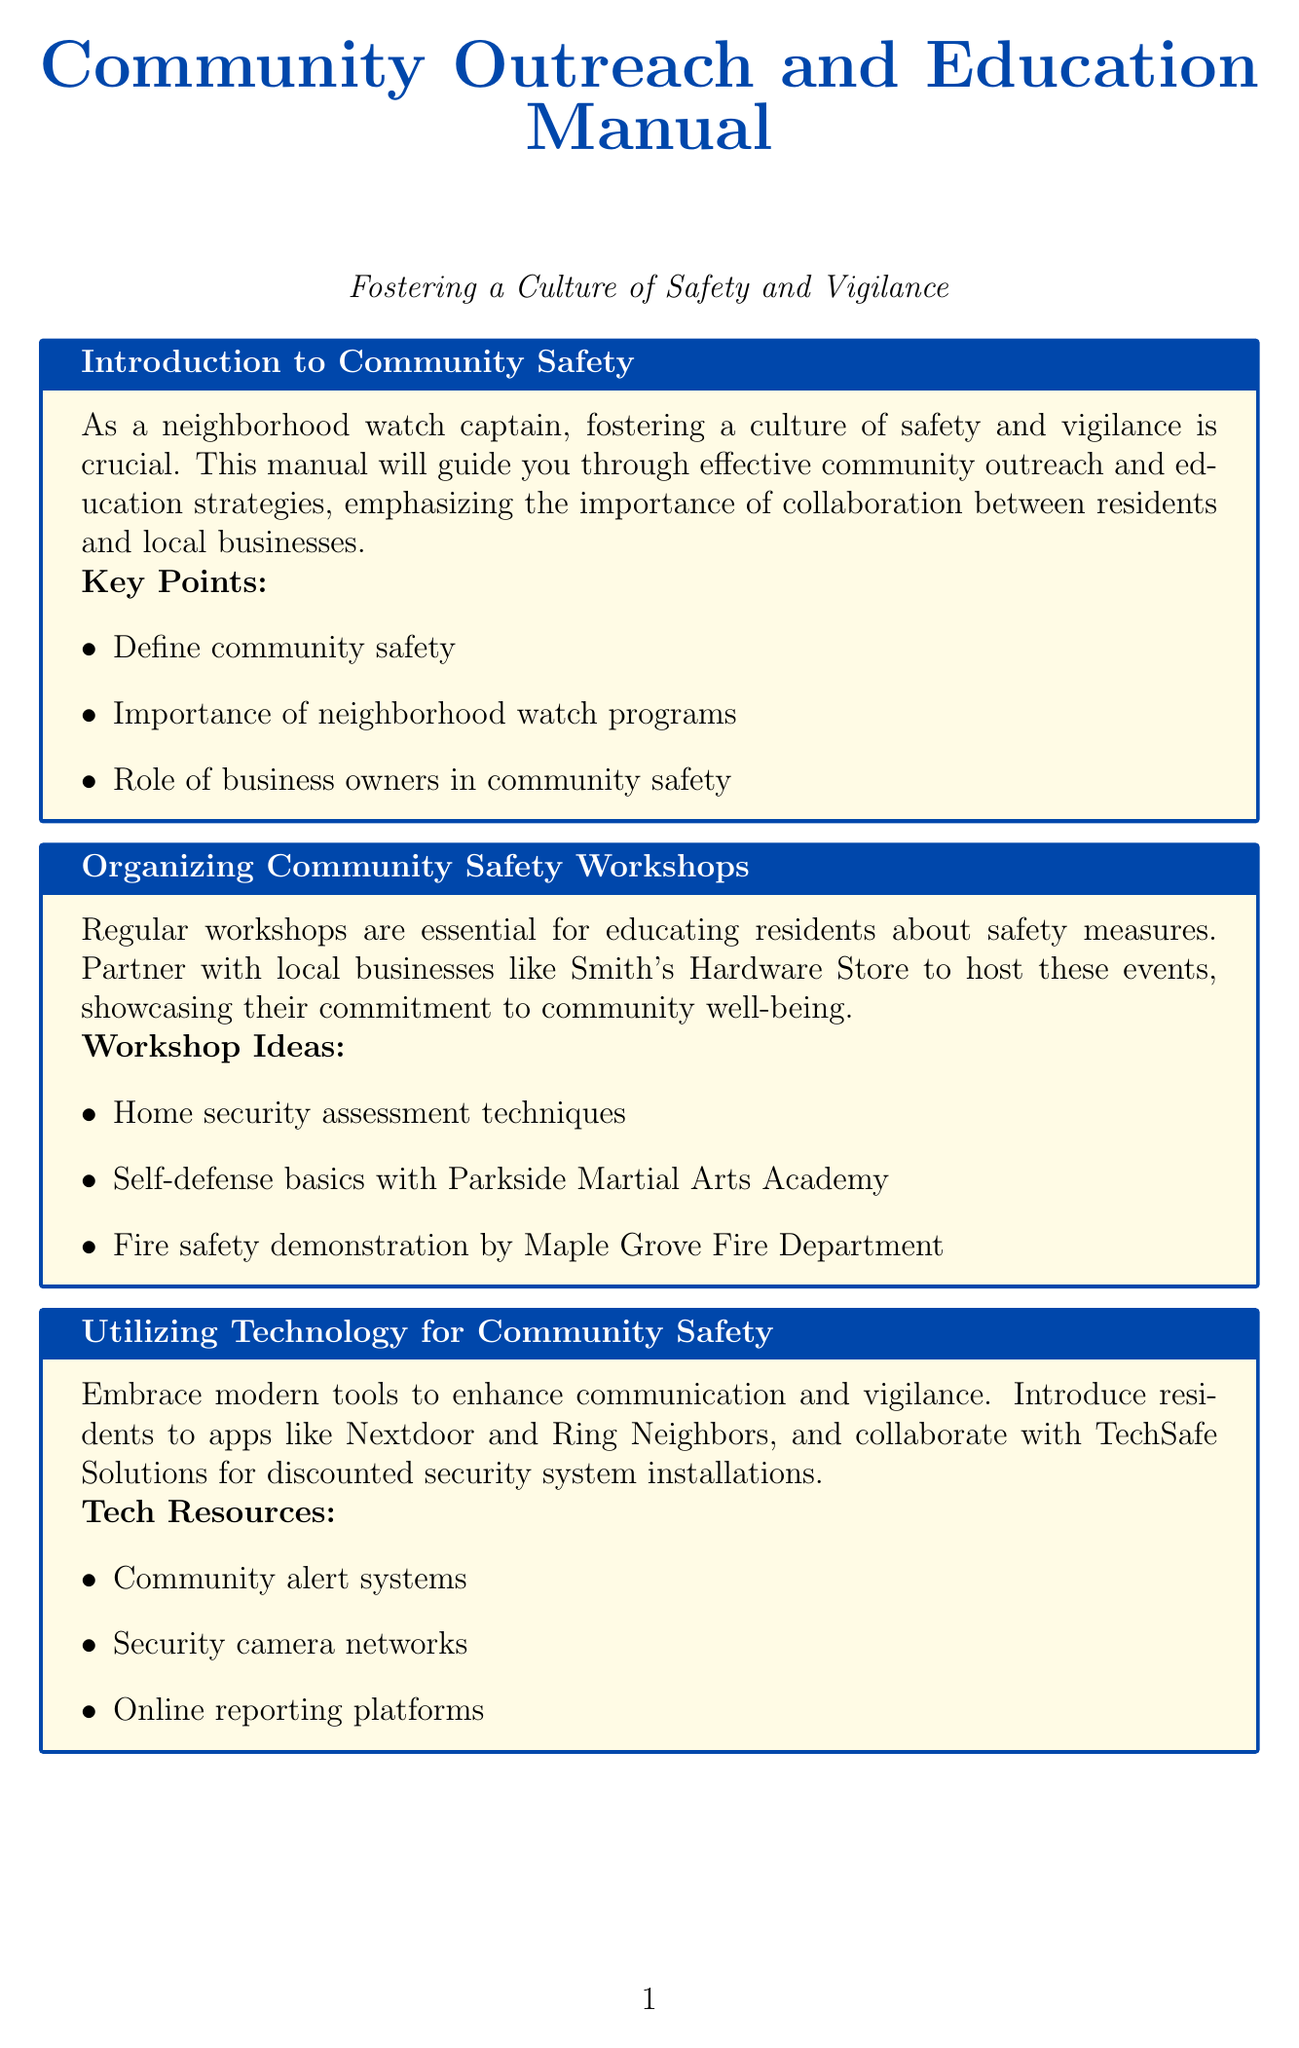What is the first section of the manual? The first section provides an introduction to community safety, outlining the importance of safety and vigilance.
Answer: Introduction to Community Safety Which local business is suggested for organizing safety workshops? Smith's Hardware Store is recommended as a partner to host community safety workshops.
Answer: Smith's Hardware Store How many workshop ideas are listed in the document? The document lists three specific workshop ideas aimed at educating residents about safety measures.
Answer: 3 What type of program is proposed for young residents? The document proposes a Junior Neighborhood Watch program to engage teenagers in safety initiatives.
Answer: Junior Neighborhood Watch program What organization is mentioned for collaboration on training sessions? The document mentions collaborating with Pinecrest Community Watch for inter-neighborhood cooperation activities.
Answer: Pinecrest Community Watch What should be tracked to demonstrate the impact of safety initiatives? The impact of initiatives should be demonstrated through the analysis of crime statistics gathered in collaboration with a police department.
Answer: Crime statistics Which local pharmacy has well-lit parking and 24/7 security cameras? The document highlights Riverside Pharmacy as having a well-lit parking lot and 24/7 security cameras contributing to neighborhood safety.
Answer: Riverside Pharmacy What is the annual community safety report used for? The annual community safety report is used to share positive trends and improvements in safety with the community.
Answer: Share positive trends What type of safety resources should be developed for residents? High-quality brochures and posters are to be developed as informative materials for residents.
Answer: Brochures and posters How often should strategy review meetings be held? The document suggests holding strategy review meetings on a quarterly basis to ensure continuous improvement.
Answer: Quarterly 